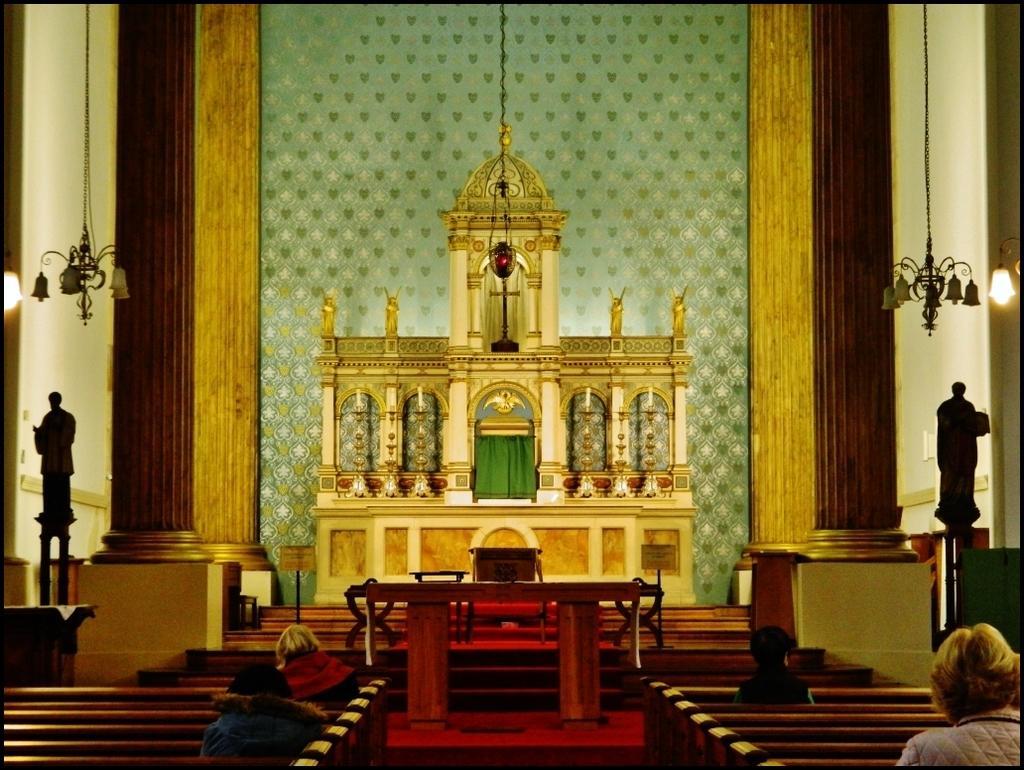Describe this image in one or two sentences. In this image we can see there are persons sitting on the bench. And there is a table, carpet, two statues, a few candles, a few lights and the wall, two pillars and the cream colored structure. 